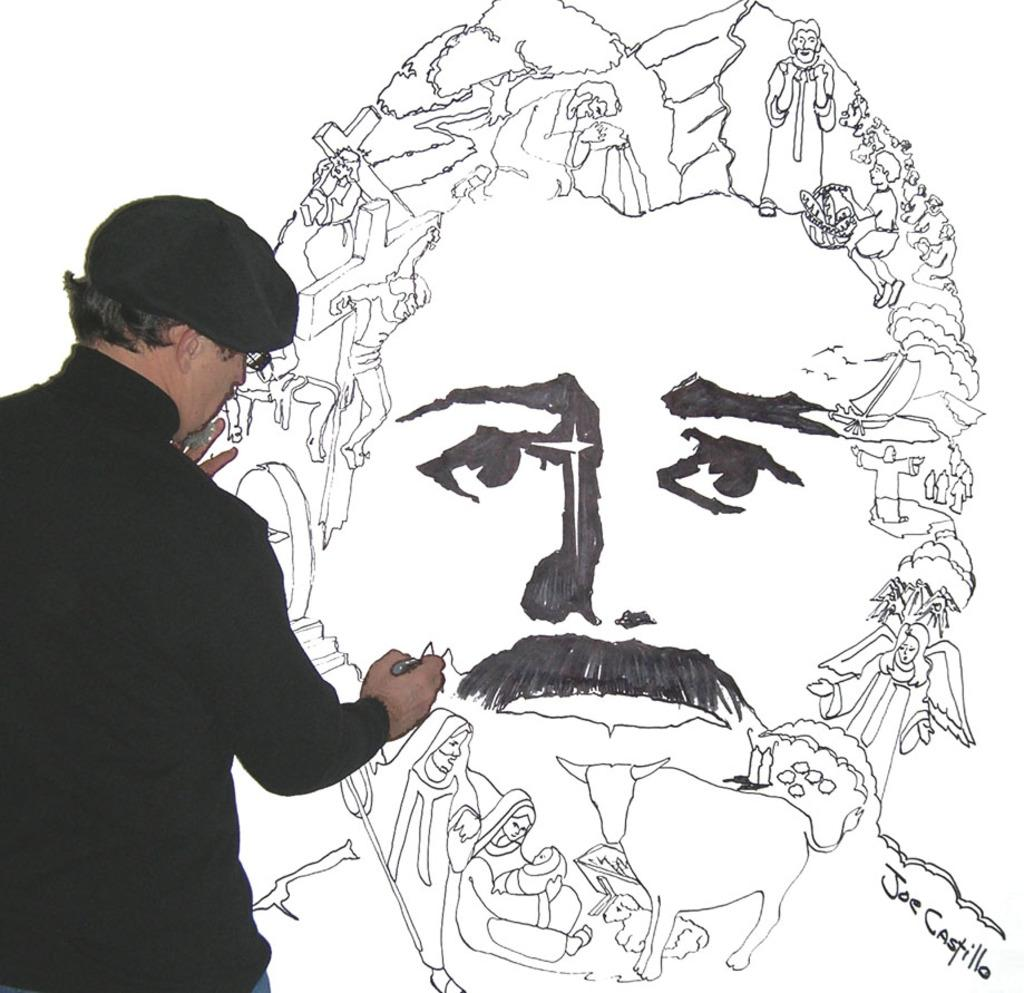Who is present on the left side of the image? There is a person on the left side of the image. What is the person wearing? The person is wearing a black dress. What can be seen in the middle of the image? There is a drawing on a white surface in the middle of the image. What type of mint is being used to sort the cream in the image? There is no mint or cream present in the image, and therefore no such activity can be observed. 